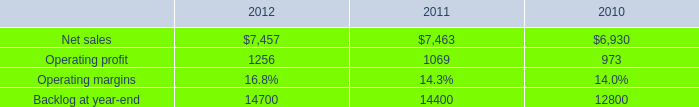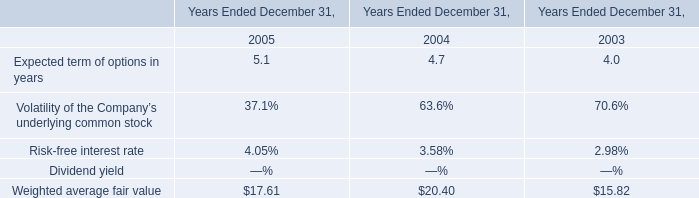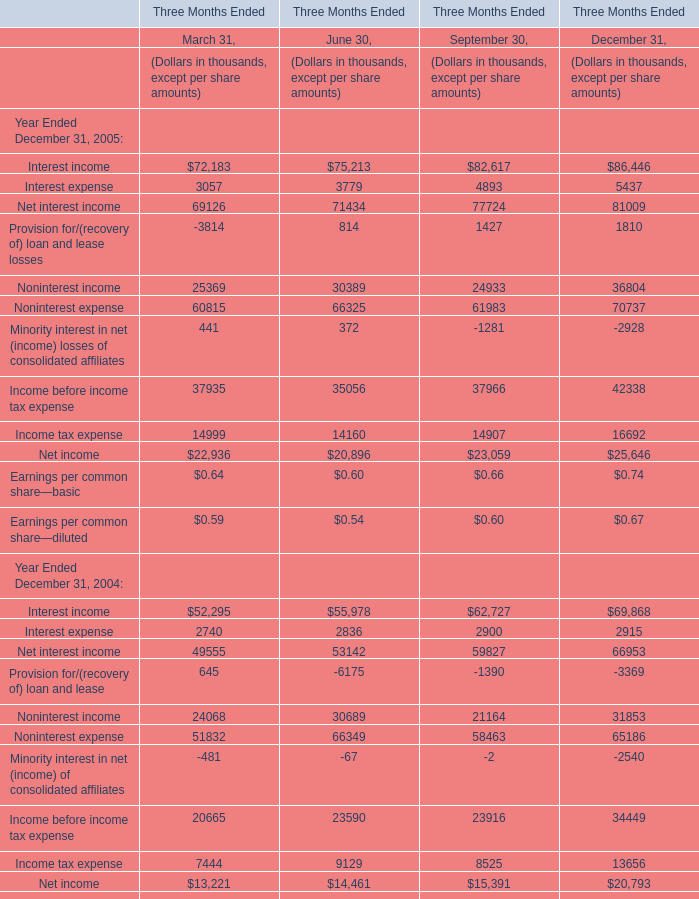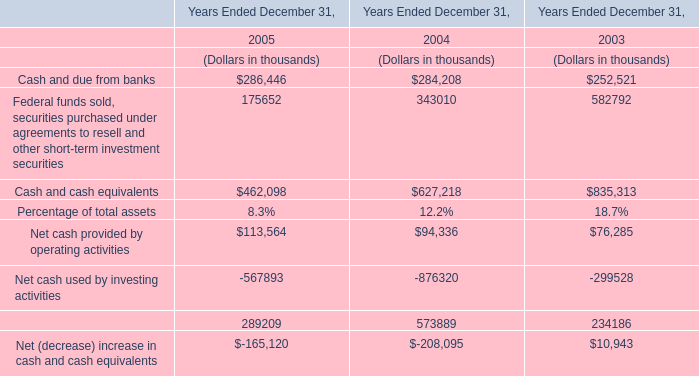What is the difference between the greatest Interest expense in 2005 and 2004？ (in thousand) 
Computations: (5437 - 2915)
Answer: 2522.0. 